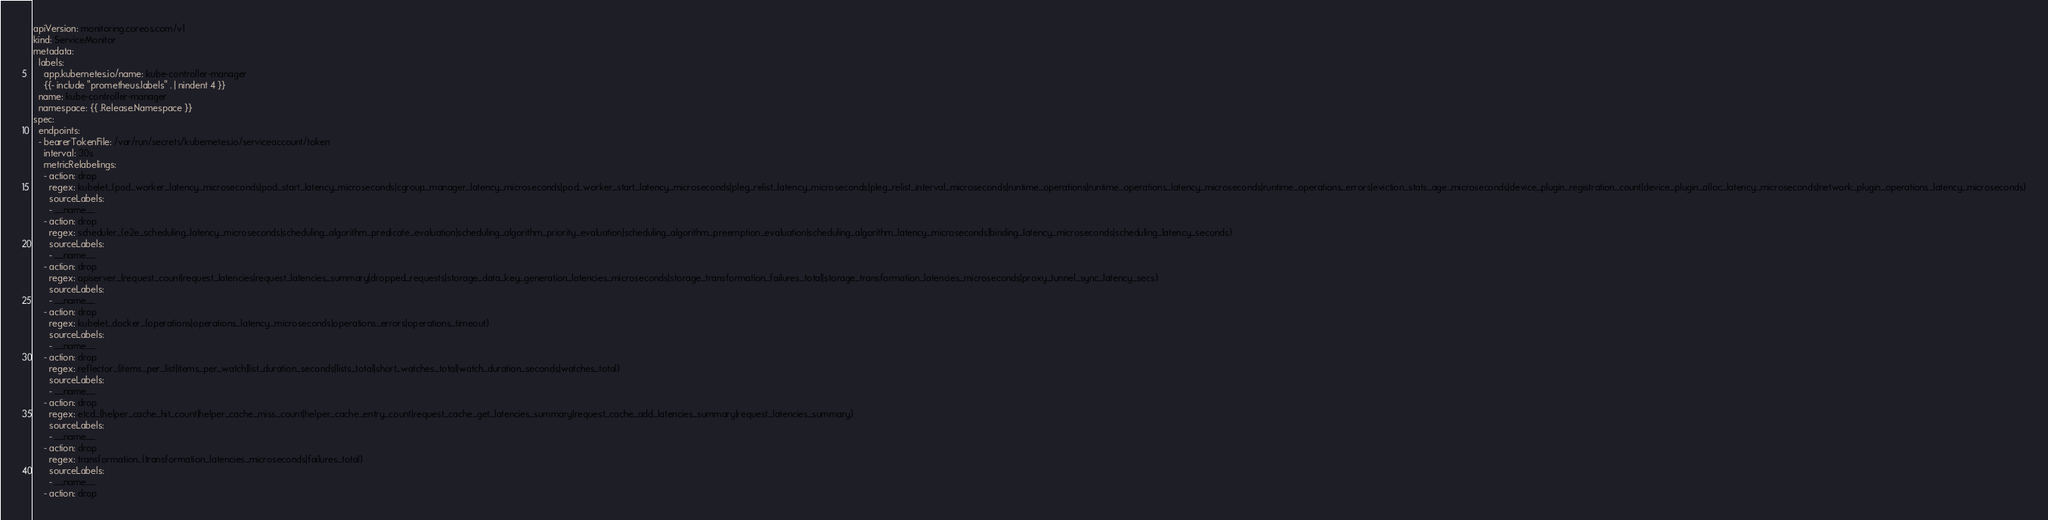Convert code to text. <code><loc_0><loc_0><loc_500><loc_500><_YAML_>apiVersion: monitoring.coreos.com/v1
kind: ServiceMonitor
metadata:
  labels:
    app.kubernetes.io/name: kube-controller-manager
    {{- include "prometheus.labels" . | nindent 4 }}
  name: kube-controller-manager
  namespace: {{ .Release.Namespace }}
spec:
  endpoints:
  - bearerTokenFile: /var/run/secrets/kubernetes.io/serviceaccount/token
    interval: 30s
    metricRelabelings:
    - action: drop
      regex: kubelet_(pod_worker_latency_microseconds|pod_start_latency_microseconds|cgroup_manager_latency_microseconds|pod_worker_start_latency_microseconds|pleg_relist_latency_microseconds|pleg_relist_interval_microseconds|runtime_operations|runtime_operations_latency_microseconds|runtime_operations_errors|eviction_stats_age_microseconds|device_plugin_registration_count|device_plugin_alloc_latency_microseconds|network_plugin_operations_latency_microseconds)
      sourceLabels:
      - __name__
    - action: drop
      regex: scheduler_(e2e_scheduling_latency_microseconds|scheduling_algorithm_predicate_evaluation|scheduling_algorithm_priority_evaluation|scheduling_algorithm_preemption_evaluation|scheduling_algorithm_latency_microseconds|binding_latency_microseconds|scheduling_latency_seconds)
      sourceLabels:
      - __name__
    - action: drop
      regex: apiserver_(request_count|request_latencies|request_latencies_summary|dropped_requests|storage_data_key_generation_latencies_microseconds|storage_transformation_failures_total|storage_transformation_latencies_microseconds|proxy_tunnel_sync_latency_secs)
      sourceLabels:
      - __name__
    - action: drop
      regex: kubelet_docker_(operations|operations_latency_microseconds|operations_errors|operations_timeout)
      sourceLabels:
      - __name__
    - action: drop
      regex: reflector_(items_per_list|items_per_watch|list_duration_seconds|lists_total|short_watches_total|watch_duration_seconds|watches_total)
      sourceLabels:
      - __name__
    - action: drop
      regex: etcd_(helper_cache_hit_count|helper_cache_miss_count|helper_cache_entry_count|request_cache_get_latencies_summary|request_cache_add_latencies_summary|request_latencies_summary)
      sourceLabels:
      - __name__
    - action: drop
      regex: transformation_(transformation_latencies_microseconds|failures_total)
      sourceLabels:
      - __name__
    - action: drop</code> 